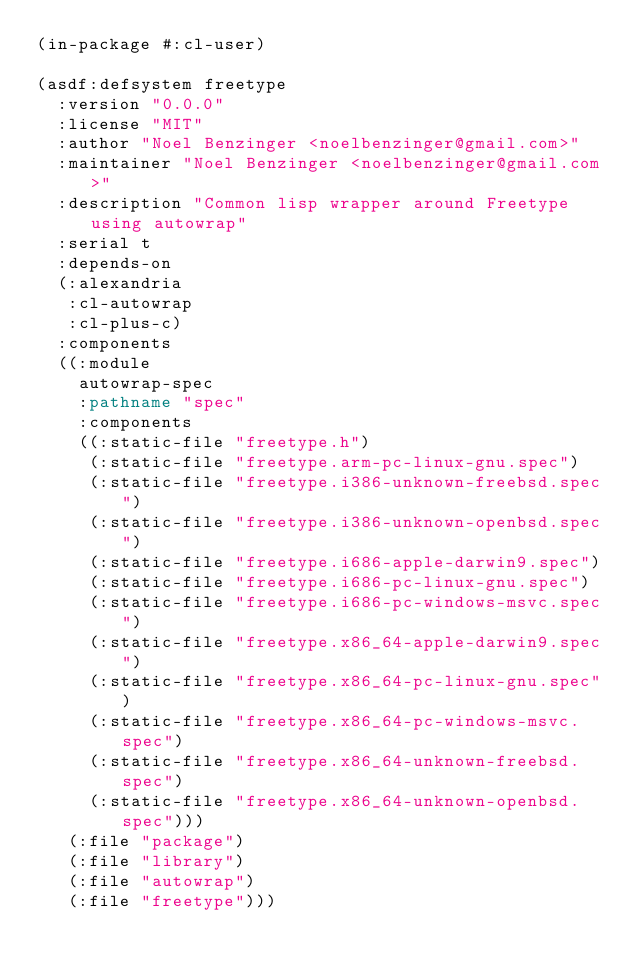<code> <loc_0><loc_0><loc_500><loc_500><_Lisp_>(in-package #:cl-user)

(asdf:defsystem freetype
  :version "0.0.0"
  :license "MIT"
  :author "Noel Benzinger <noelbenzinger@gmail.com>"
  :maintainer "Noel Benzinger <noelbenzinger@gmail.com>"
  :description "Common lisp wrapper around Freetype using autowrap"
  :serial t
  :depends-on
  (:alexandria
   :cl-autowrap
   :cl-plus-c)
  :components
  ((:module
    autowrap-spec
    :pathname "spec"
    :components
    ((:static-file "freetype.h")
     (:static-file "freetype.arm-pc-linux-gnu.spec")
     (:static-file "freetype.i386-unknown-freebsd.spec")
     (:static-file "freetype.i386-unknown-openbsd.spec")
     (:static-file "freetype.i686-apple-darwin9.spec")
     (:static-file "freetype.i686-pc-linux-gnu.spec")
     (:static-file "freetype.i686-pc-windows-msvc.spec")
     (:static-file "freetype.x86_64-apple-darwin9.spec")
     (:static-file "freetype.x86_64-pc-linux-gnu.spec")
     (:static-file "freetype.x86_64-pc-windows-msvc.spec")
     (:static-file "freetype.x86_64-unknown-freebsd.spec")
     (:static-file "freetype.x86_64-unknown-openbsd.spec")))
   (:file "package")
   (:file "library")
   (:file "autowrap")
   (:file "freetype")))
</code> 